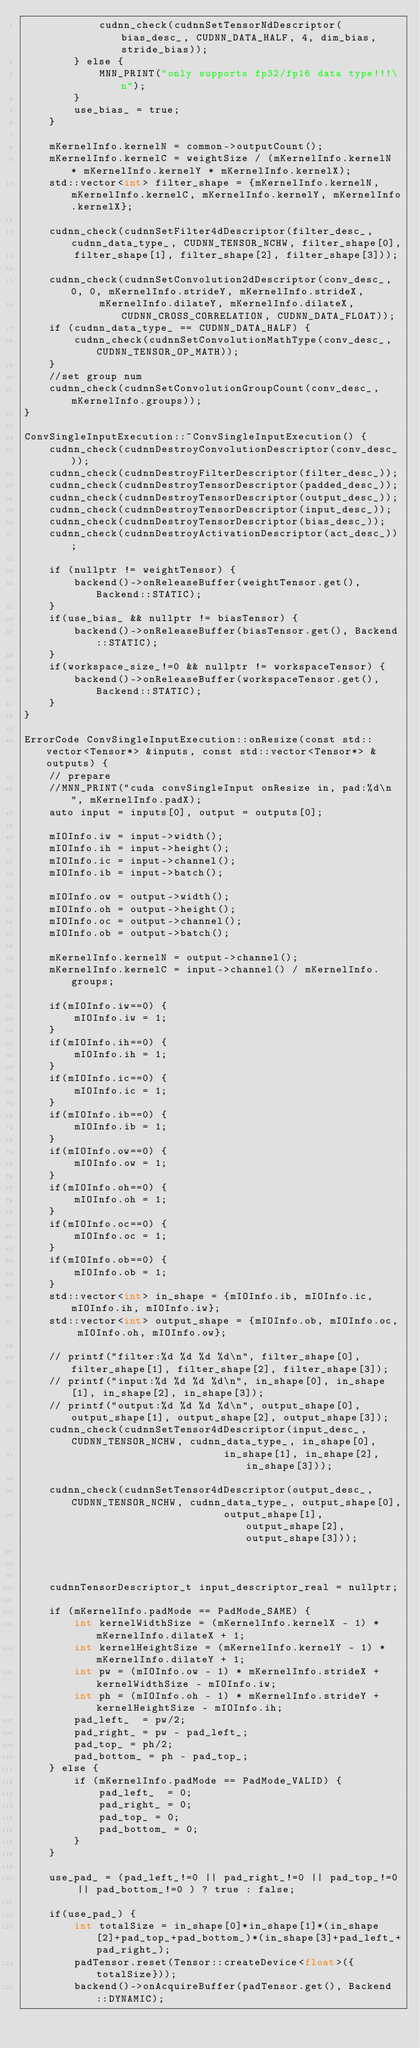Convert code to text. <code><loc_0><loc_0><loc_500><loc_500><_Cuda_>            cudnn_check(cudnnSetTensorNdDescriptor(bias_desc_, CUDNN_DATA_HALF, 4, dim_bias, stride_bias));
        } else {
            MNN_PRINT("only supports fp32/fp16 data type!!!\n");
        }
        use_bias_ = true;
    }

    mKernelInfo.kernelN = common->outputCount();
    mKernelInfo.kernelC = weightSize / (mKernelInfo.kernelN * mKernelInfo.kernelY * mKernelInfo.kernelX);
    std::vector<int> filter_shape = {mKernelInfo.kernelN, mKernelInfo.kernelC, mKernelInfo.kernelY, mKernelInfo.kernelX};

    cudnn_check(cudnnSetFilter4dDescriptor(filter_desc_, cudnn_data_type_, CUDNN_TENSOR_NCHW, filter_shape[0],
        filter_shape[1], filter_shape[2], filter_shape[3]));

    cudnn_check(cudnnSetConvolution2dDescriptor(conv_desc_, 0, 0, mKernelInfo.strideY, mKernelInfo.strideX, 
            mKernelInfo.dilateY, mKernelInfo.dilateX, CUDNN_CROSS_CORRELATION, CUDNN_DATA_FLOAT));
    if (cudnn_data_type_ == CUDNN_DATA_HALF) {
        cudnn_check(cudnnSetConvolutionMathType(conv_desc_, CUDNN_TENSOR_OP_MATH));
    }
    //set group num
    cudnn_check(cudnnSetConvolutionGroupCount(conv_desc_, mKernelInfo.groups));
}

ConvSingleInputExecution::~ConvSingleInputExecution() {
    cudnn_check(cudnnDestroyConvolutionDescriptor(conv_desc_));
    cudnn_check(cudnnDestroyFilterDescriptor(filter_desc_));
    cudnn_check(cudnnDestroyTensorDescriptor(padded_desc_));
    cudnn_check(cudnnDestroyTensorDescriptor(output_desc_));
    cudnn_check(cudnnDestroyTensorDescriptor(input_desc_));
    cudnn_check(cudnnDestroyTensorDescriptor(bias_desc_));
    cudnn_check(cudnnDestroyActivationDescriptor(act_desc_));

    if (nullptr != weightTensor) {
        backend()->onReleaseBuffer(weightTensor.get(), Backend::STATIC);
    }
    if(use_bias_ && nullptr != biasTensor) {
        backend()->onReleaseBuffer(biasTensor.get(), Backend::STATIC);
    }
    if(workspace_size_!=0 && nullptr != workspaceTensor) {
        backend()->onReleaseBuffer(workspaceTensor.get(), Backend::STATIC);
    }
}

ErrorCode ConvSingleInputExecution::onResize(const std::vector<Tensor*> &inputs, const std::vector<Tensor*> &outputs) {
    // prepare
    //MNN_PRINT("cuda convSingleInput onResize in, pad:%d\n", mKernelInfo.padX);
    auto input = inputs[0], output = outputs[0];

    mIOInfo.iw = input->width();
    mIOInfo.ih = input->height();
    mIOInfo.ic = input->channel();
    mIOInfo.ib = input->batch();
    
    mIOInfo.ow = output->width();
    mIOInfo.oh = output->height();
    mIOInfo.oc = output->channel();
    mIOInfo.ob = output->batch();

    mKernelInfo.kernelN = output->channel();
    mKernelInfo.kernelC = input->channel() / mKernelInfo.groups;

    if(mIOInfo.iw==0) {
        mIOInfo.iw = 1;
    }
    if(mIOInfo.ih==0) {
        mIOInfo.ih = 1;
    }
    if(mIOInfo.ic==0) {
        mIOInfo.ic = 1;
    }
    if(mIOInfo.ib==0) {
        mIOInfo.ib = 1;
    }
    if(mIOInfo.ow==0) {
        mIOInfo.ow = 1;
    }
    if(mIOInfo.oh==0) {
        mIOInfo.oh = 1;
    }
    if(mIOInfo.oc==0) {
        mIOInfo.oc = 1;
    }
    if(mIOInfo.ob==0) {
        mIOInfo.ob = 1;
    }
    std::vector<int> in_shape = {mIOInfo.ib, mIOInfo.ic, mIOInfo.ih, mIOInfo.iw};
    std::vector<int> output_shape = {mIOInfo.ob, mIOInfo.oc, mIOInfo.oh, mIOInfo.ow};
    
    // printf("filter:%d %d %d %d\n", filter_shape[0], filter_shape[1], filter_shape[2], filter_shape[3]);
    // printf("input:%d %d %d %d\n", in_shape[0], in_shape[1], in_shape[2], in_shape[3]);
    // printf("output:%d %d %d %d\n", output_shape[0], output_shape[1], output_shape[2], output_shape[3]);
    cudnn_check(cudnnSetTensor4dDescriptor(input_desc_, CUDNN_TENSOR_NCHW, cudnn_data_type_, in_shape[0],
                                in_shape[1], in_shape[2], in_shape[3]));

    cudnn_check(cudnnSetTensor4dDescriptor(output_desc_, CUDNN_TENSOR_NCHW, cudnn_data_type_, output_shape[0],
                                output_shape[1], output_shape[2], output_shape[3]));

    

    cudnnTensorDescriptor_t input_descriptor_real = nullptr;

    if (mKernelInfo.padMode == PadMode_SAME) {
        int kernelWidthSize = (mKernelInfo.kernelX - 1) * mKernelInfo.dilateX + 1;
        int kernelHeightSize = (mKernelInfo.kernelY - 1) * mKernelInfo.dilateY + 1;
        int pw = (mIOInfo.ow - 1) * mKernelInfo.strideX + kernelWidthSize - mIOInfo.iw;
        int ph = (mIOInfo.oh - 1) * mKernelInfo.strideY + kernelHeightSize - mIOInfo.ih;
        pad_left_  = pw/2;
        pad_right_ = pw - pad_left_;
        pad_top_ = ph/2;
        pad_bottom_ = ph - pad_top_;
    } else {
        if (mKernelInfo.padMode == PadMode_VALID) {
            pad_left_  = 0;
            pad_right_ = 0;
            pad_top_ = 0;
            pad_bottom_ = 0;
        }
    }

    use_pad_ = (pad_left_!=0 || pad_right_!=0 || pad_top_!=0 || pad_bottom_!=0 ) ? true : false;

    if(use_pad_) {
        int totalSize = in_shape[0]*in_shape[1]*(in_shape[2]+pad_top_+pad_bottom_)*(in_shape[3]+pad_left_+pad_right_);
        padTensor.reset(Tensor::createDevice<float>({totalSize}));
        backend()->onAcquireBuffer(padTensor.get(), Backend::DYNAMIC);</code> 